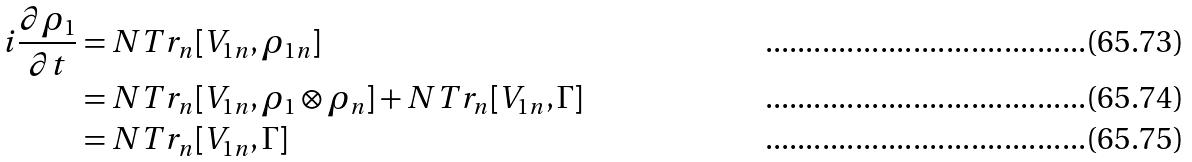Convert formula to latex. <formula><loc_0><loc_0><loc_500><loc_500>i \frac { \partial \rho _ { 1 } } { \partial t } & = N T r _ { n } [ V _ { 1 n } , \rho _ { 1 n } ] \\ & = N T r _ { n } [ V _ { 1 n } , \rho _ { 1 } \otimes \rho _ { n } ] + N T r _ { n } [ V _ { 1 n } , \Gamma ] \\ & = N T r _ { n } [ V _ { 1 n } , \Gamma ]</formula> 